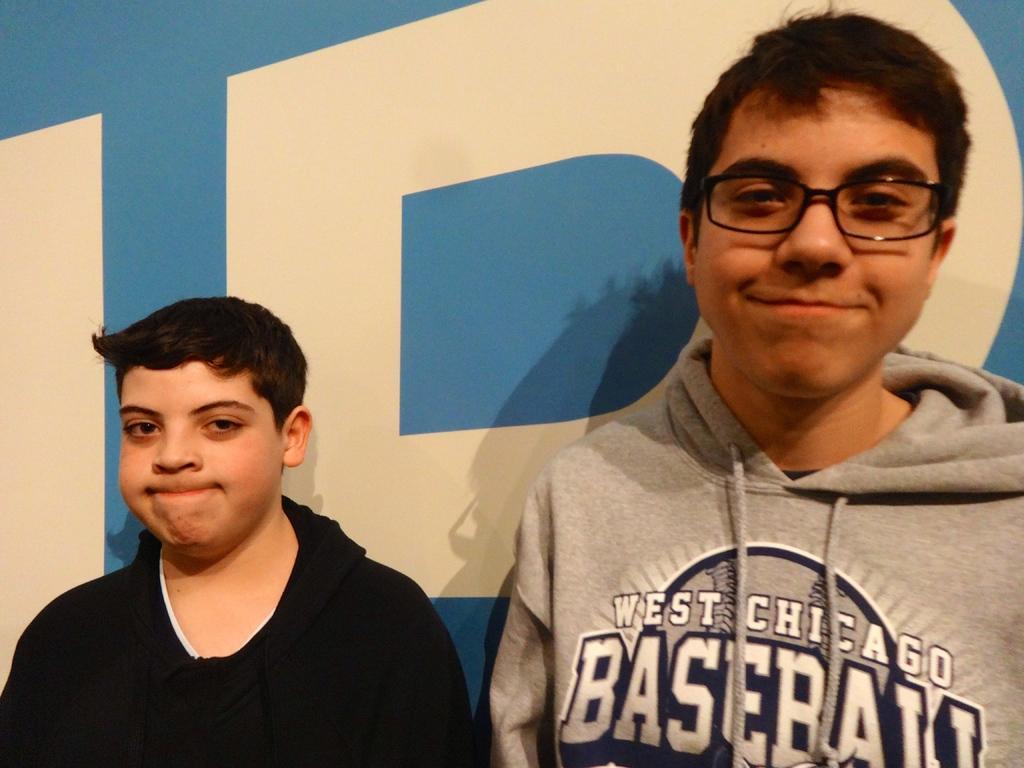Please provide a concise description of this image. In this picture, there are two boys. A boy towards the left, he is wearing a black jacket. A boy towards the right, wearing a grey jacket. In the background there is a wall with some text. 